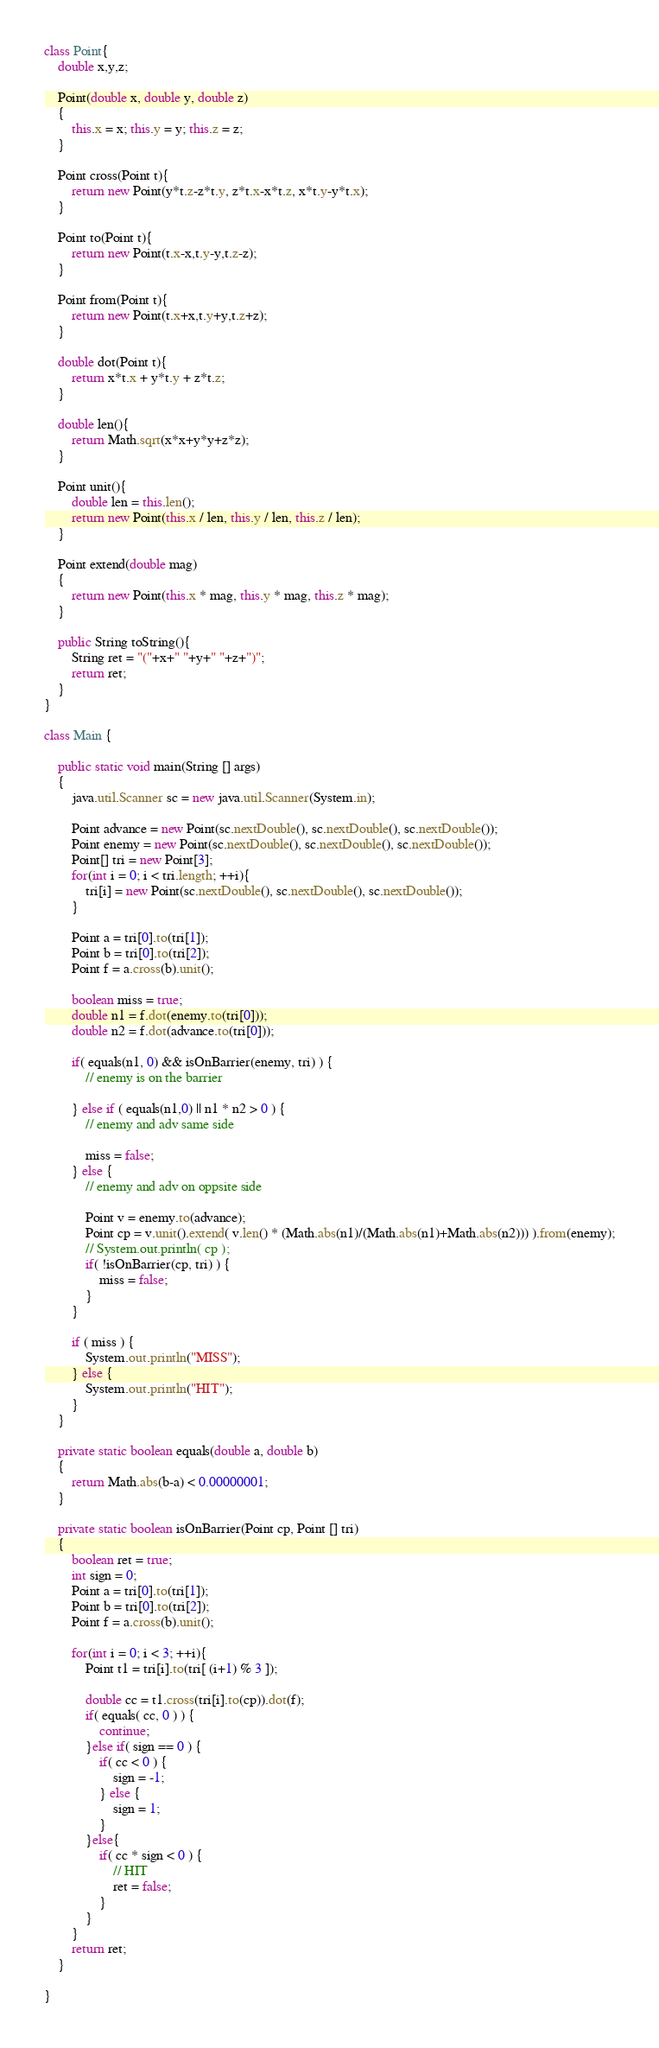<code> <loc_0><loc_0><loc_500><loc_500><_Java_>class Point{
	double x,y,z;
	
	Point(double x, double y, double z)
	{
		this.x = x; this.y = y; this.z = z;
	}
	
	Point cross(Point t){
		return new Point(y*t.z-z*t.y, z*t.x-x*t.z, x*t.y-y*t.x);
	}
	
	Point to(Point t){
		return new Point(t.x-x,t.y-y,t.z-z);
	}
	
	Point from(Point t){
		return new Point(t.x+x,t.y+y,t.z+z);
	}
	
	double dot(Point t){
		return x*t.x + y*t.y + z*t.z;
	}
	
	double len(){
		return Math.sqrt(x*x+y*y+z*z);
	}
	
	Point unit(){
		double len = this.len();
		return new Point(this.x / len, this.y / len, this.z / len);
	}
	
	Point extend(double mag)
	{
		return new Point(this.x * mag, this.y * mag, this.z * mag);
	}
	
	public String toString(){
		String ret = "("+x+" "+y+" "+z+")";
		return ret;
	}
}

class Main {
	
	public static void main(String [] args)
	{
		java.util.Scanner sc = new java.util.Scanner(System.in);
		
		Point advance = new Point(sc.nextDouble(), sc.nextDouble(), sc.nextDouble());
		Point enemy = new Point(sc.nextDouble(), sc.nextDouble(), sc.nextDouble());
		Point[] tri = new Point[3];
		for(int i = 0; i < tri.length; ++i){
			tri[i] = new Point(sc.nextDouble(), sc.nextDouble(), sc.nextDouble());
		}
		
		Point a = tri[0].to(tri[1]);
		Point b = tri[0].to(tri[2]);
		Point f = a.cross(b).unit();
		
		boolean miss = true;
		double n1 = f.dot(enemy.to(tri[0]));
		double n2 = f.dot(advance.to(tri[0]));
		
		if( equals(n1, 0) && isOnBarrier(enemy, tri) ) {
			// enemy is on the barrier
			
		} else if ( equals(n1,0) || n1 * n2 > 0 ) {
			// enemy and adv same side
			
			miss = false;
		} else {
			// enemy and adv on oppsite side
			
			Point v = enemy.to(advance);
			Point cp = v.unit().extend( v.len() * (Math.abs(n1)/(Math.abs(n1)+Math.abs(n2))) ).from(enemy);
			// System.out.println( cp );
			if( !isOnBarrier(cp, tri) ) {
				miss = false;
			}
		}
		
		if ( miss ) {
			System.out.println("MISS");
		} else {
			System.out.println("HIT");
		}
	}
	
	private static boolean equals(double a, double b)
	{
		return Math.abs(b-a) < 0.00000001;
	}

	private static boolean isOnBarrier(Point cp, Point [] tri)
	{
		boolean ret = true;
		int sign = 0;
		Point a = tri[0].to(tri[1]);
		Point b = tri[0].to(tri[2]);
		Point f = a.cross(b).unit();

		for(int i = 0; i < 3; ++i){
			Point t1 = tri[i].to(tri[ (i+1) % 3 ]);
			
			double cc = t1.cross(tri[i].to(cp)).dot(f);
			if( equals( cc, 0 ) ) {
				continue;
			}else if( sign == 0 ) {
				if( cc < 0 ) {
					sign = -1;
				} else {
					sign = 1;
				}
			}else{
				if( cc * sign < 0 ) {
					// HIT
					ret = false;
				}
			}
		}
		return ret;
	}
	
}</code> 